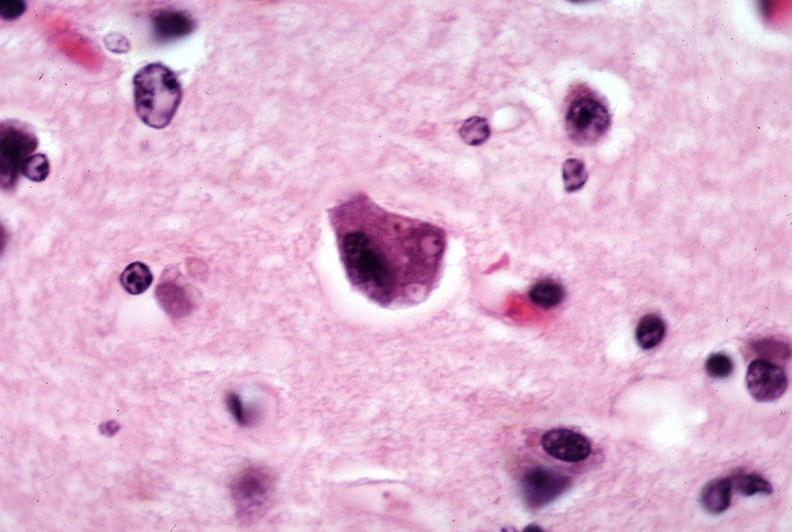does this image show brain, pick 's disease?
Answer the question using a single word or phrase. Yes 